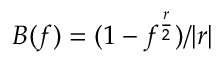Convert formula to latex. <formula><loc_0><loc_0><loc_500><loc_500>B ( f ) = ( 1 - f ^ { \frac { r } { 2 } } ) / | r |</formula> 